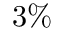Convert formula to latex. <formula><loc_0><loc_0><loc_500><loc_500>3 \%</formula> 